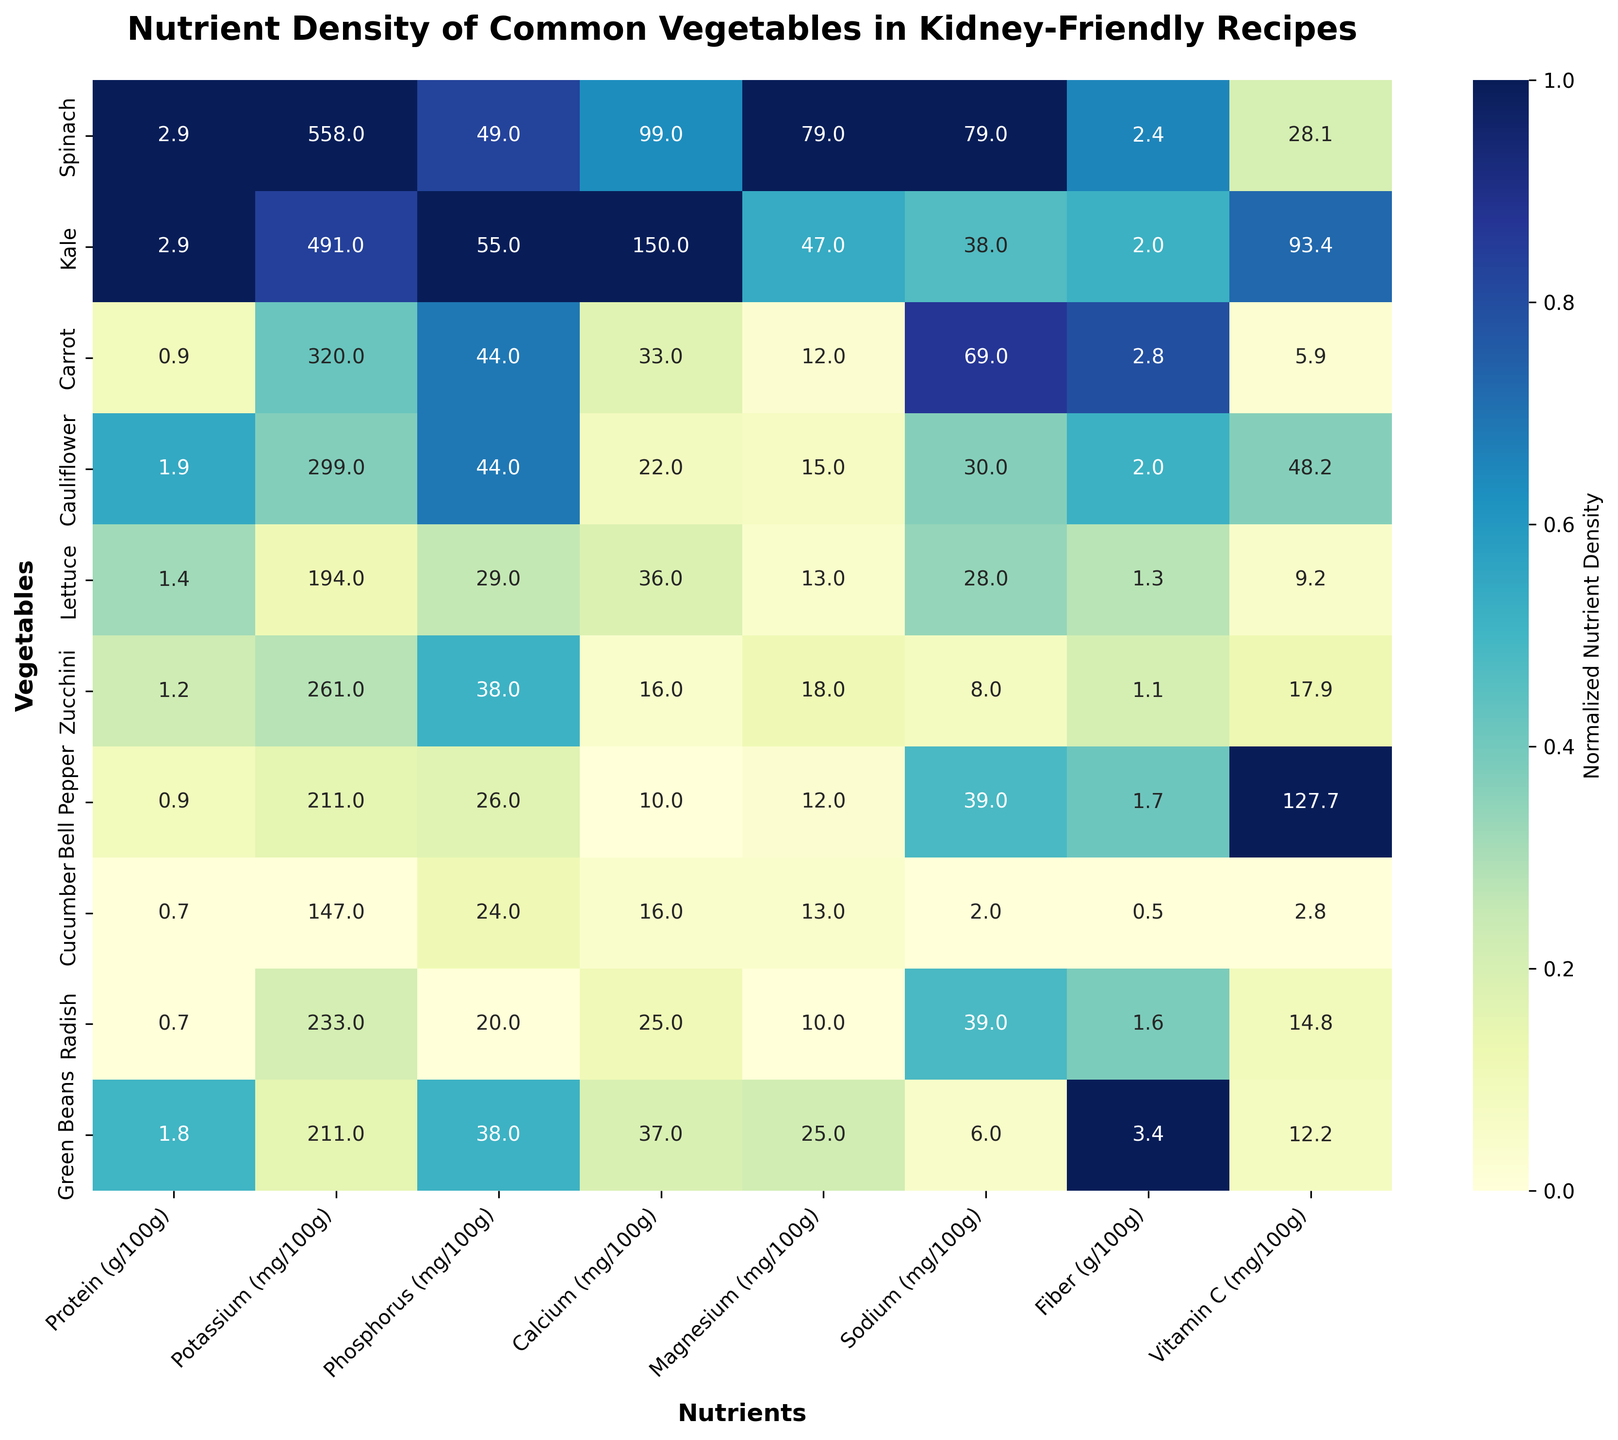Which vegetable has the highest normalized nutrient density for Vitamin C? According to the heatmap, Bell Pepper shows the highest annotated value for Vitamin C, indicating it has the highest normalized nutrient density for this nutrient.
Answer: Bell Pepper What is the range of normalized nutrient densities for Calcium across all vegetables? To determine the range, observe the highest and lowest values of Calcium in the heatmap. Spinach has the highest value and Bell Pepper has the lowest.
Answer: Spinach to Bell Pepper Which nutrient does Spinach have the relatively highest concentration of, based on normalized values? Look at the row corresponding to Spinach and identify which column has the darkest shade. For Spinach, the nutrient with the darkest shade is Calcium.
Answer: Calcium Compare the normalized nutrient densities for Fiber between Kale and Green Beans. Which one has a higher value? Look at the Fiber column and compare the shades for Kale and Green Beans. Green Beans has a darker shade, indicating a higher concentration.
Answer: Green Beans Which nutrient shows the least normalized variance across different vegetables? Identify the column with the most uniformly colored shades. Sodium appears to have the least variance as the shades are most similar.
Answer: Sodium What is the normalized nutrient density of Potassium in Lettuce compared to Radish? Locate the Potassium column and compare the shades and annotated values for Lettuce and Radish. Radish has a higher annotated value, indicating higher normalized nutrient density.
Answer: Radish How does the normalized nutrient density of Phosphorus in Cauliflower compare to that in Carrot? Check the Phosphorus column for the shades and annotated values of Cauliflower and Carrot. Both have nearly similar values, indicating similar nutrient densities.
Answer: Similar Calculate the average normalized nutrient density of Protein for all vegetables. Add up all the normalized Protein values and divide by the number of vegetables (10). The annotated values for Protein must be normalized before summing. A rough estimate can be made by averaging the values visible.
Answer: Approximately (depends on the exact normalized values) Which nutrient has the highest min-to-max difference in normalized nutrient density? Look for the nutrient column with the darkest and lightest shades. Vitamin C has the broadest range, indicating the highest min-to-max difference.
Answer: Vitamin C 